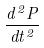<formula> <loc_0><loc_0><loc_500><loc_500>\frac { d ^ { 2 } P } { d t ^ { 2 } }</formula> 